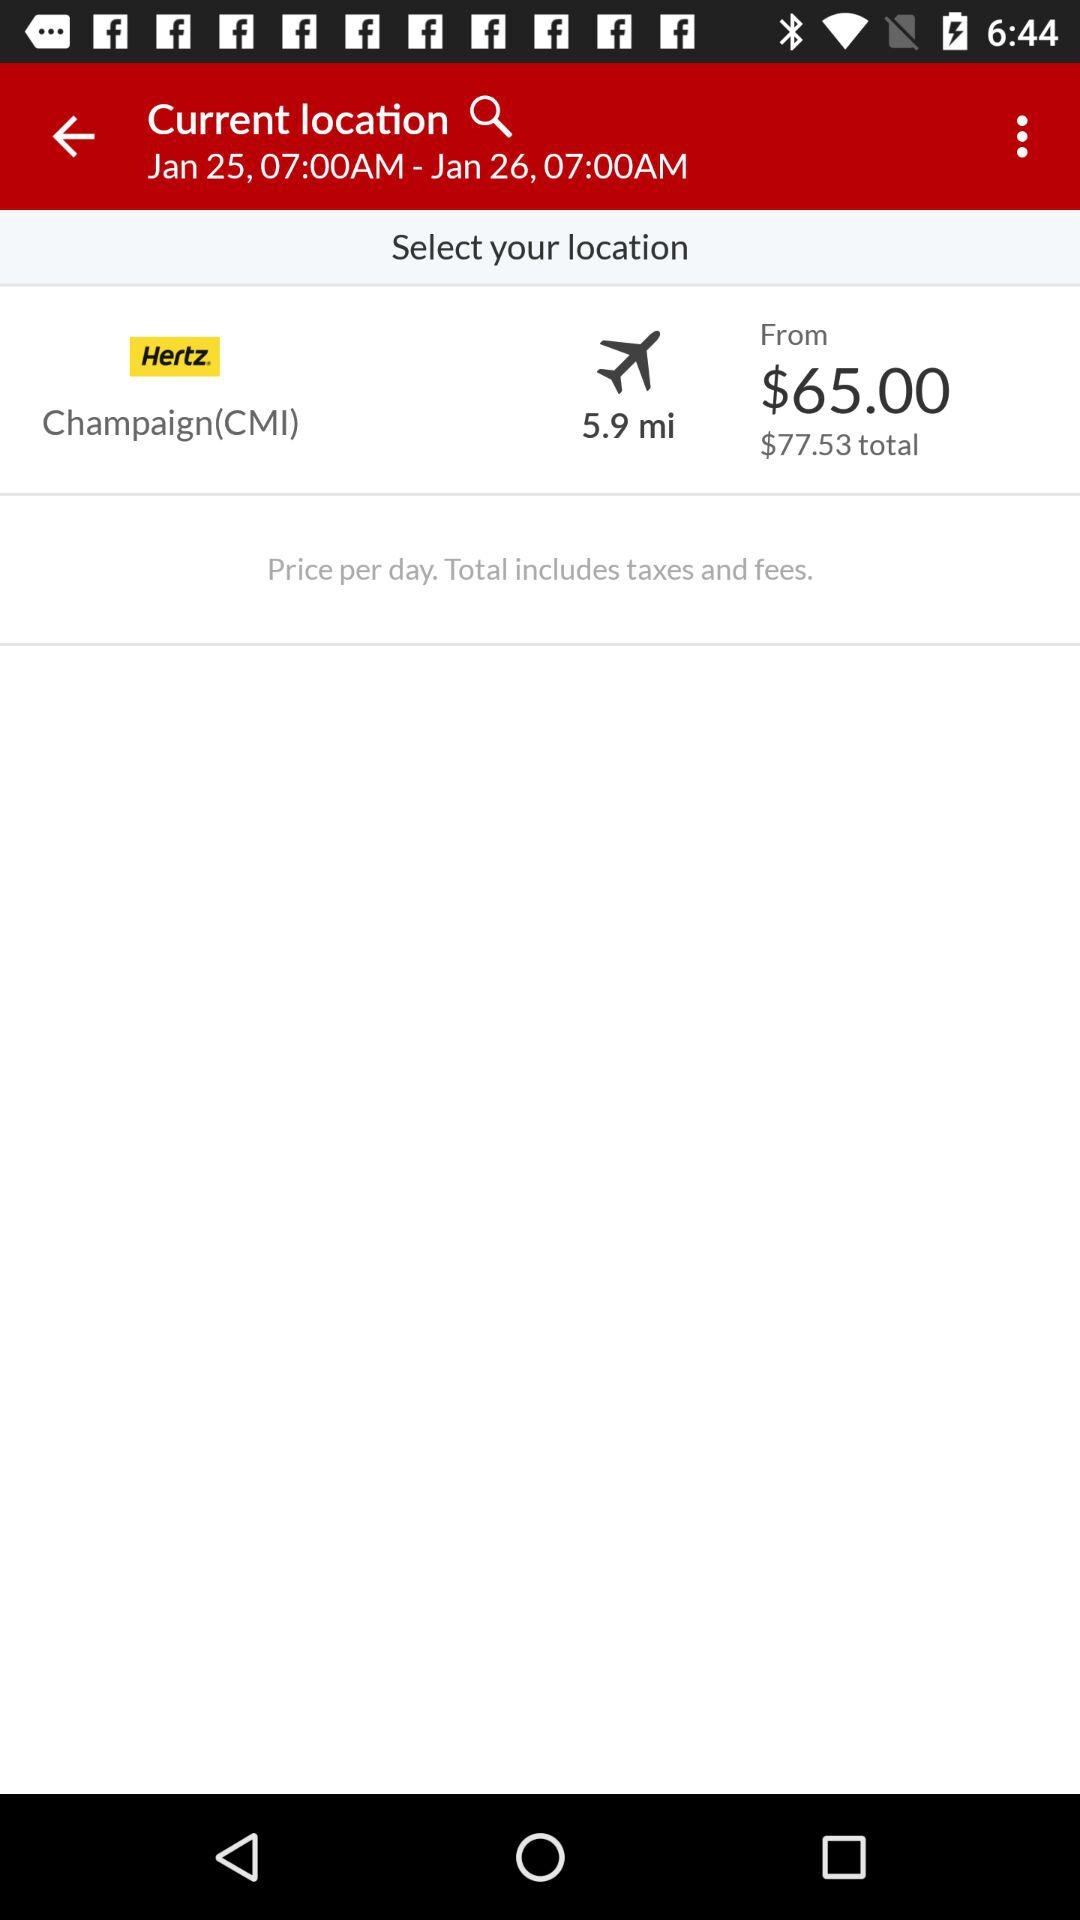How many miles is the airport from the rental location?
Answer the question using a single word or phrase. 5.9 